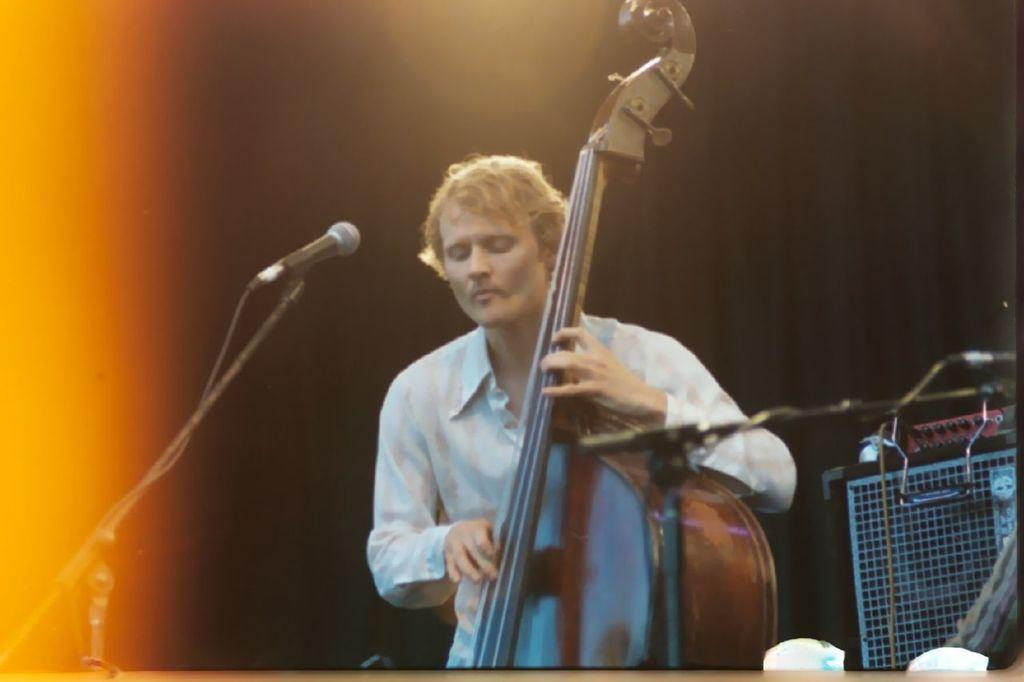Who is the main subject in the image? There is a man in the image. What is the man doing in the image? The man is performing. What instrument is the man holding in the image? The man is holding a violin. What device is in front of the man in the image? There is a microphone in front of the man. What type of spy equipment can be seen in the man's hand in the image? There is no spy equipment visible in the man's hand in the image; he is holding a violin. 